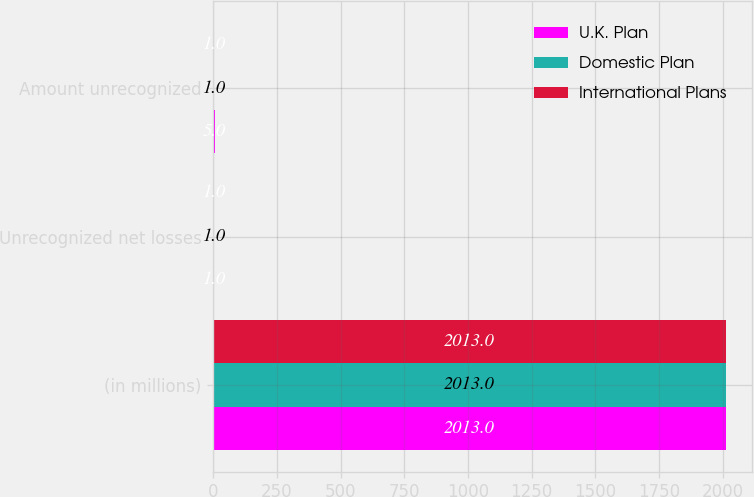Convert chart to OTSL. <chart><loc_0><loc_0><loc_500><loc_500><stacked_bar_chart><ecel><fcel>(in millions)<fcel>Unrecognized net losses<fcel>Amount unrecognized<nl><fcel>U.K. Plan<fcel>2013<fcel>1<fcel>5<nl><fcel>Domestic Plan<fcel>2013<fcel>1<fcel>1<nl><fcel>International Plans<fcel>2013<fcel>1<fcel>1<nl></chart> 